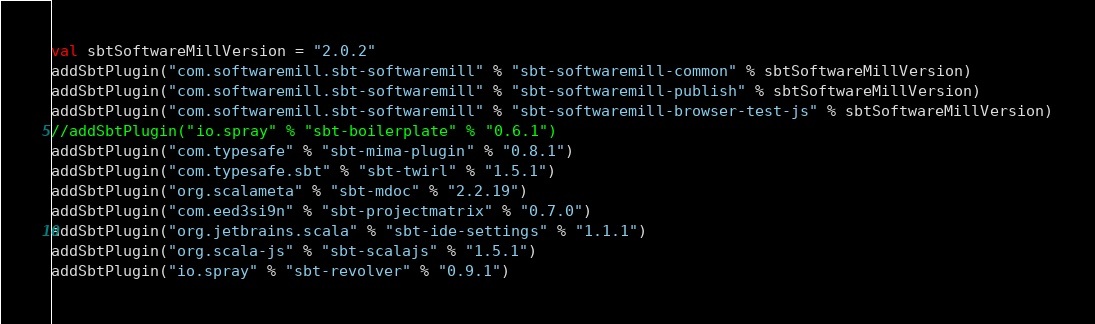<code> <loc_0><loc_0><loc_500><loc_500><_Scala_>val sbtSoftwareMillVersion = "2.0.2"
addSbtPlugin("com.softwaremill.sbt-softwaremill" % "sbt-softwaremill-common" % sbtSoftwareMillVersion)
addSbtPlugin("com.softwaremill.sbt-softwaremill" % "sbt-softwaremill-publish" % sbtSoftwareMillVersion)
addSbtPlugin("com.softwaremill.sbt-softwaremill" % "sbt-softwaremill-browser-test-js" % sbtSoftwareMillVersion)
//addSbtPlugin("io.spray" % "sbt-boilerplate" % "0.6.1")
addSbtPlugin("com.typesafe" % "sbt-mima-plugin" % "0.8.1")
addSbtPlugin("com.typesafe.sbt" % "sbt-twirl" % "1.5.1")
addSbtPlugin("org.scalameta" % "sbt-mdoc" % "2.2.19")
addSbtPlugin("com.eed3si9n" % "sbt-projectmatrix" % "0.7.0")
addSbtPlugin("org.jetbrains.scala" % "sbt-ide-settings" % "1.1.1")
addSbtPlugin("org.scala-js" % "sbt-scalajs" % "1.5.1")
addSbtPlugin("io.spray" % "sbt-revolver" % "0.9.1")
</code> 